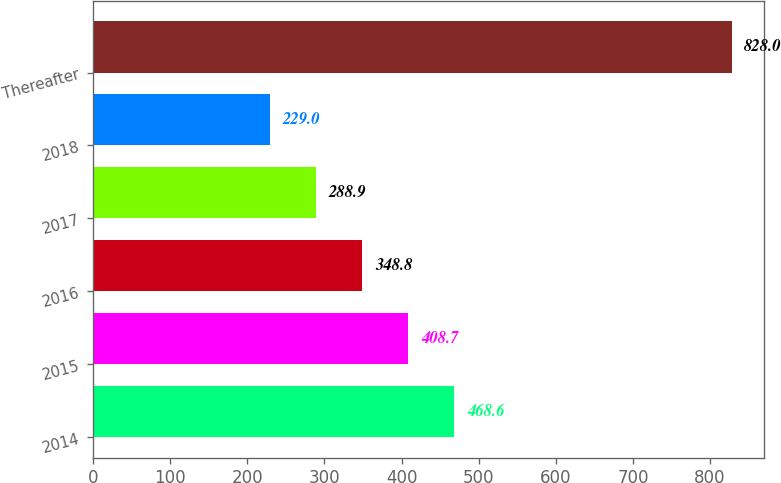Convert chart to OTSL. <chart><loc_0><loc_0><loc_500><loc_500><bar_chart><fcel>2014<fcel>2015<fcel>2016<fcel>2017<fcel>2018<fcel>Thereafter<nl><fcel>468.6<fcel>408.7<fcel>348.8<fcel>288.9<fcel>229<fcel>828<nl></chart> 